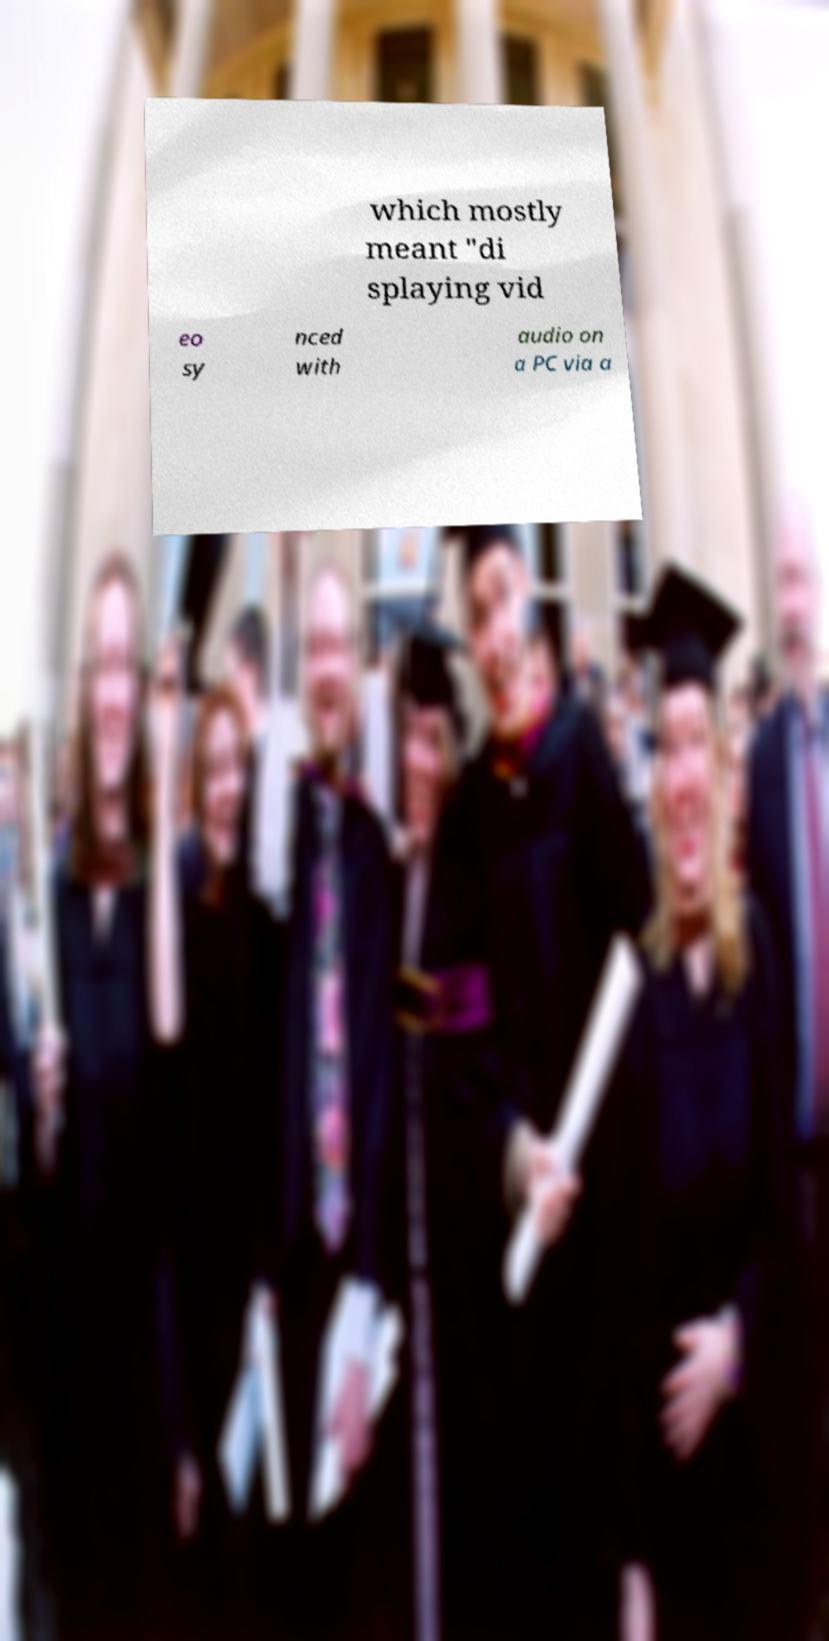Can you accurately transcribe the text from the provided image for me? which mostly meant "di splaying vid eo sy nced with audio on a PC via a 